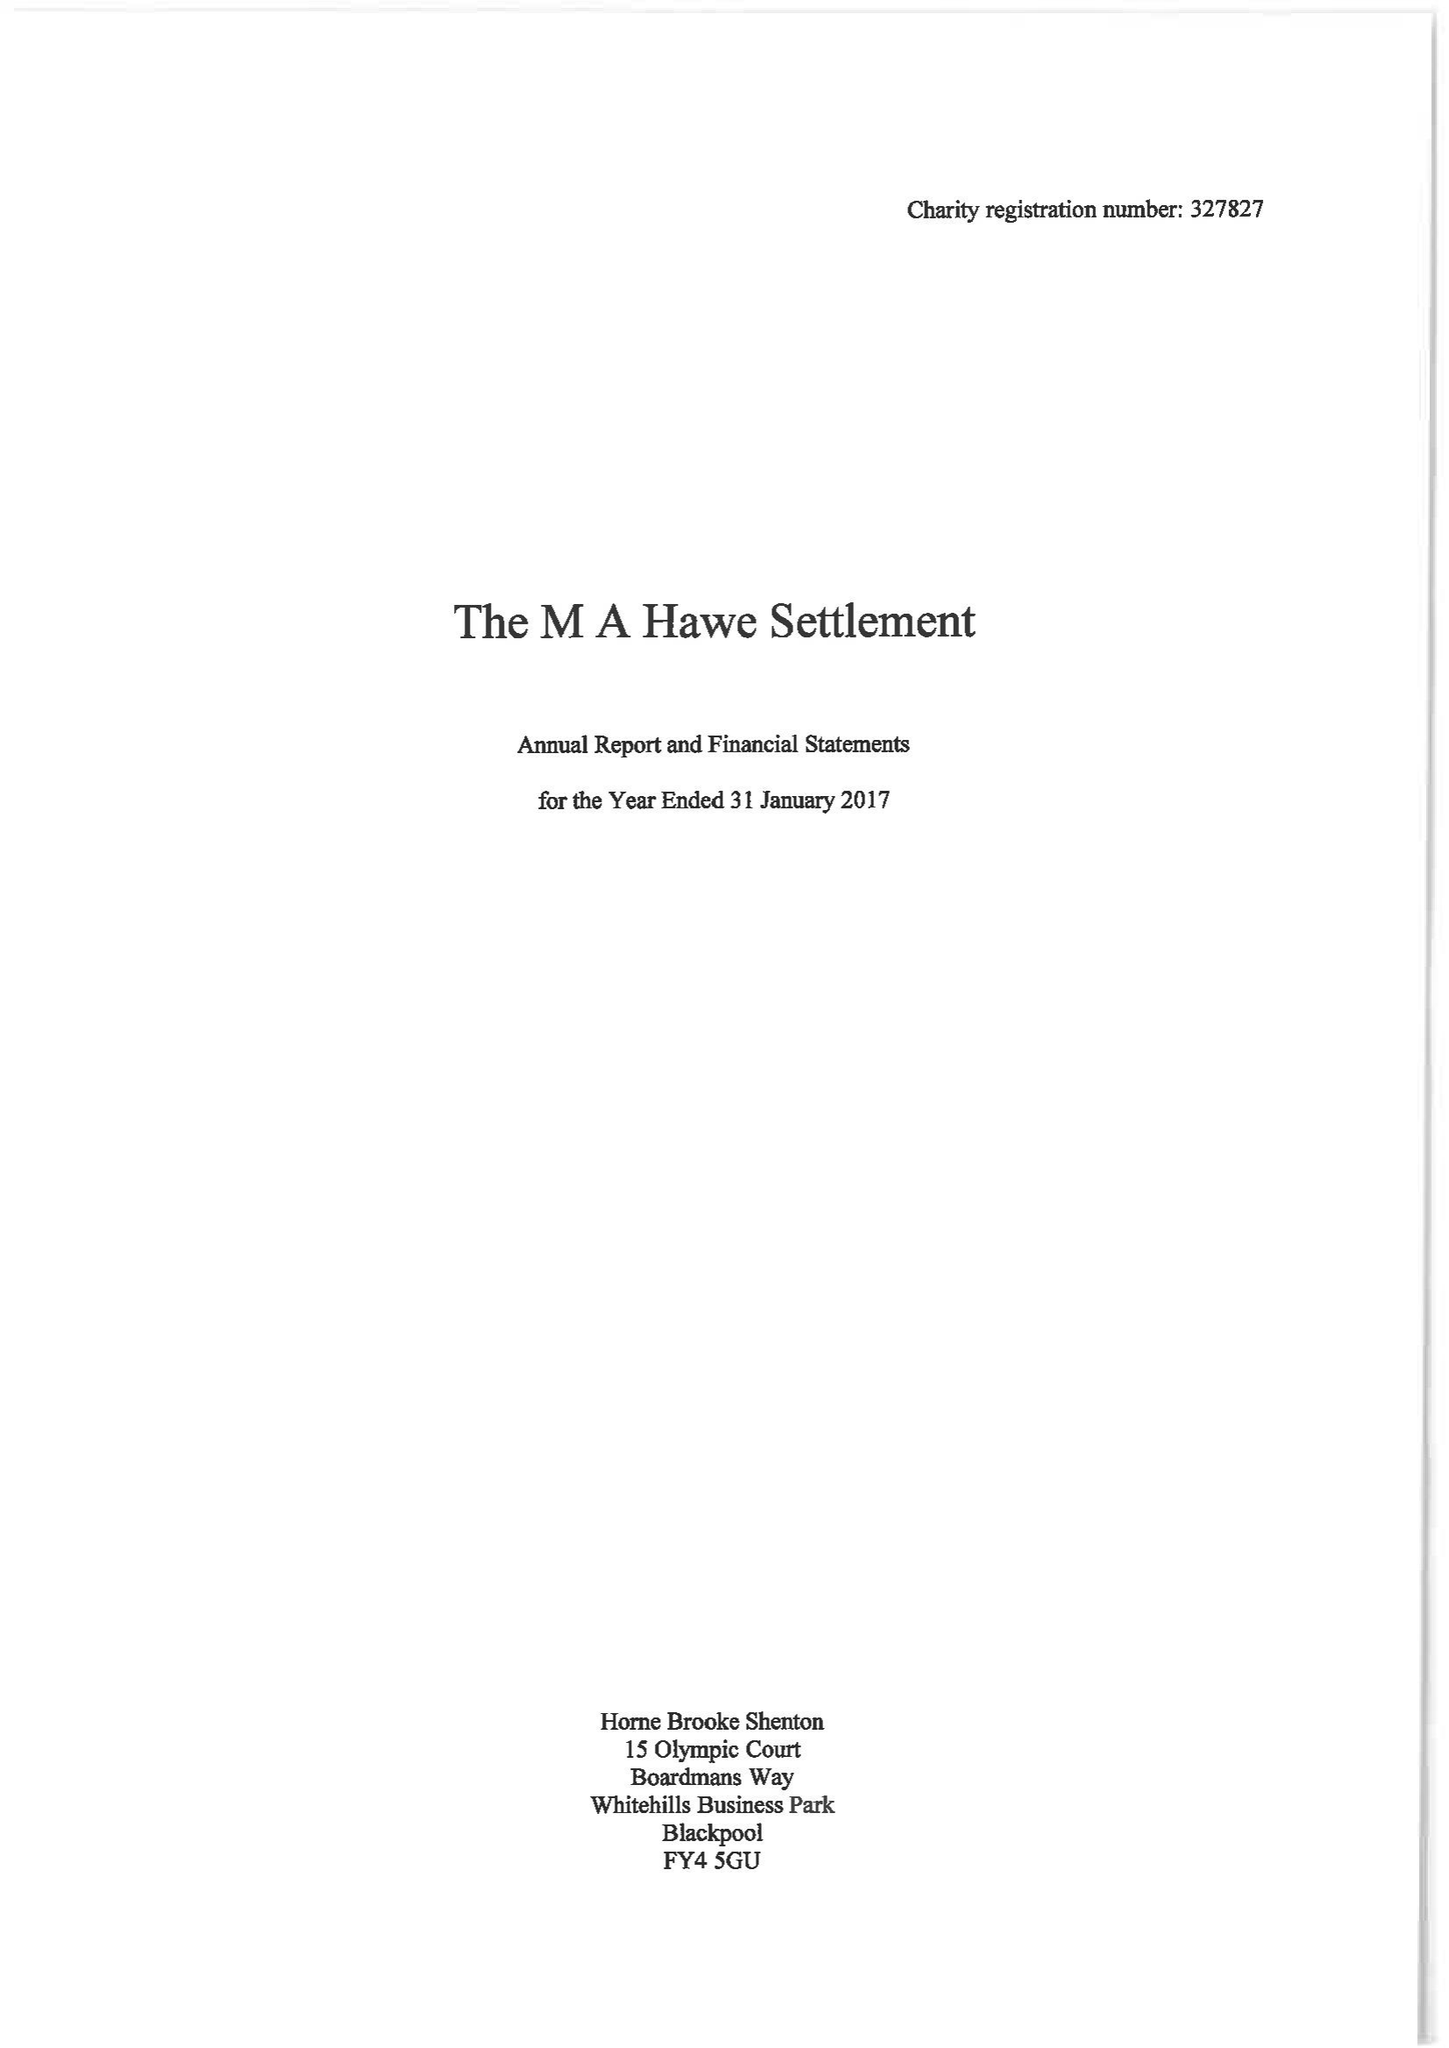What is the value for the address__postcode?
Answer the question using a single word or phrase. FY8 4JF 